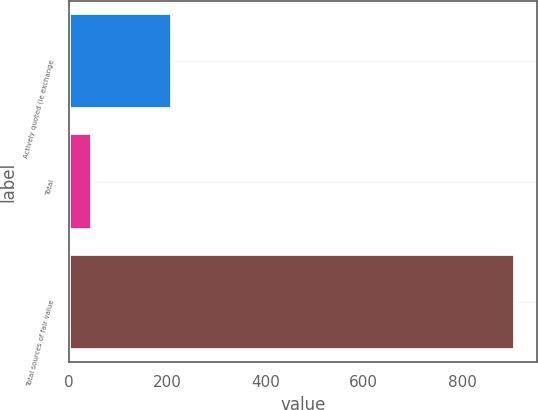<chart> <loc_0><loc_0><loc_500><loc_500><bar_chart><fcel>Actively quoted (ie exchange<fcel>Total<fcel>Total sources of fair value<nl><fcel>211<fcel>48<fcel>907<nl></chart> 